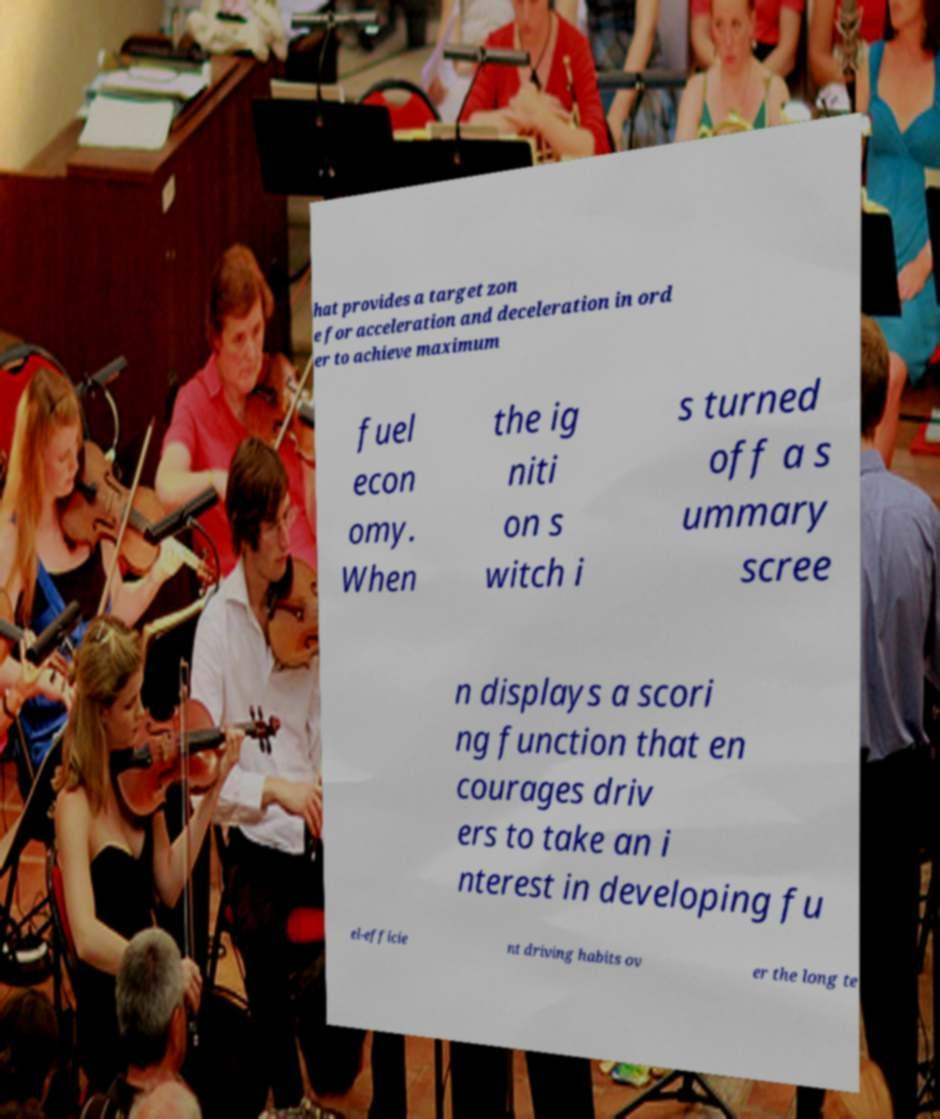What messages or text are displayed in this image? I need them in a readable, typed format. hat provides a target zon e for acceleration and deceleration in ord er to achieve maximum fuel econ omy. When the ig niti on s witch i s turned off a s ummary scree n displays a scori ng function that en courages driv ers to take an i nterest in developing fu el-efficie nt driving habits ov er the long te 